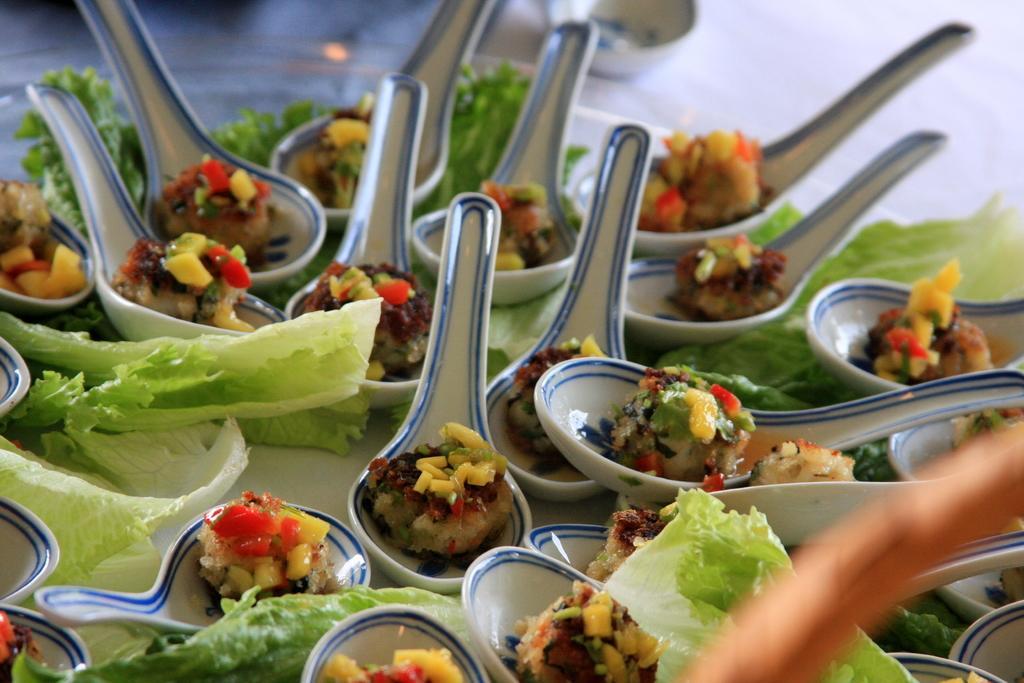Please provide a concise description of this image. In this image I can see few food items in the spoons and the food items are in green, yellow, red and brown color and the spoons are in white and blue color. 